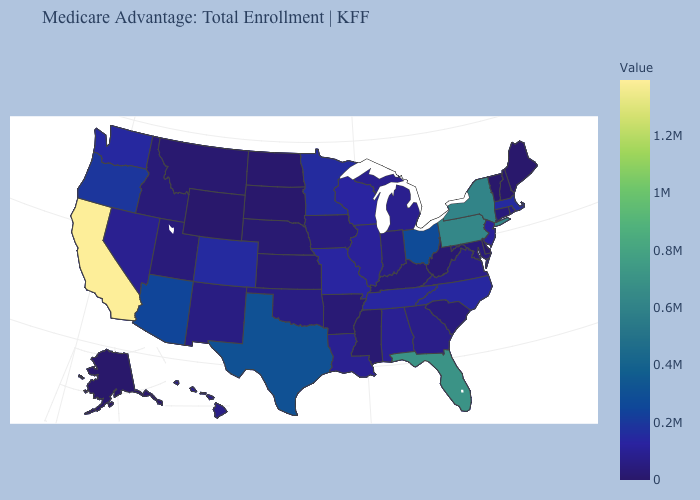Is the legend a continuous bar?
Give a very brief answer. Yes. Does Maryland have the highest value in the South?
Give a very brief answer. No. Which states hav the highest value in the South?
Quick response, please. Florida. Does Ohio have a higher value than New York?
Write a very short answer. No. Is the legend a continuous bar?
Short answer required. Yes. 